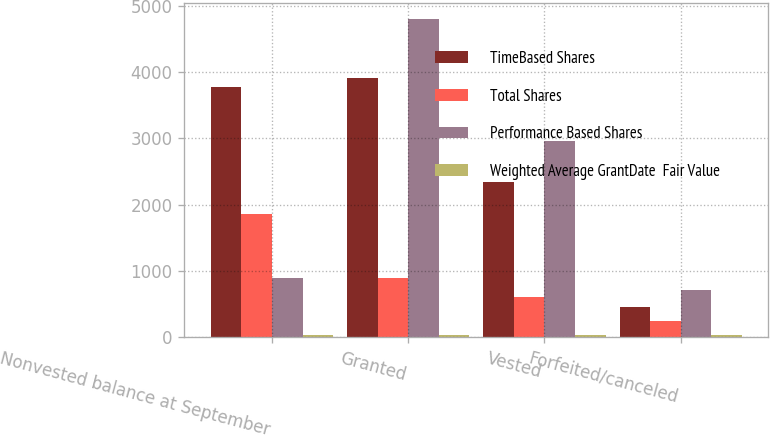Convert chart to OTSL. <chart><loc_0><loc_0><loc_500><loc_500><stacked_bar_chart><ecel><fcel>Nonvested balance at September<fcel>Granted<fcel>Vested<fcel>Forfeited/canceled<nl><fcel>TimeBased Shares<fcel>3778<fcel>3906<fcel>2347<fcel>459<nl><fcel>Total Shares<fcel>1854<fcel>897<fcel>606<fcel>250<nl><fcel>Performance Based Shares<fcel>897<fcel>4803<fcel>2953<fcel>709<nl><fcel>Weighted Average GrantDate  Fair Value<fcel>34.06<fcel>30.75<fcel>35.8<fcel>36.23<nl></chart> 